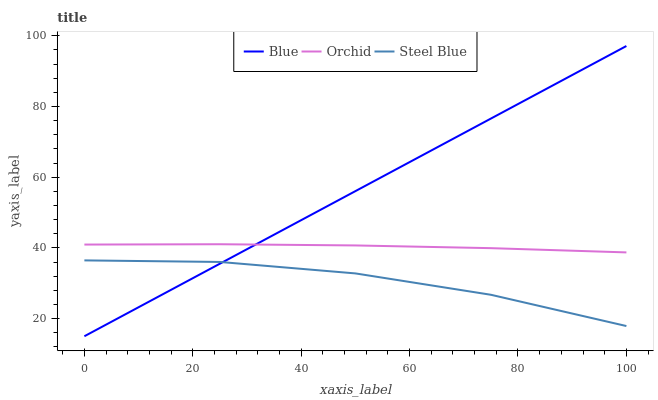Does Steel Blue have the minimum area under the curve?
Answer yes or no. Yes. Does Blue have the maximum area under the curve?
Answer yes or no. Yes. Does Orchid have the minimum area under the curve?
Answer yes or no. No. Does Orchid have the maximum area under the curve?
Answer yes or no. No. Is Blue the smoothest?
Answer yes or no. Yes. Is Steel Blue the roughest?
Answer yes or no. Yes. Is Orchid the smoothest?
Answer yes or no. No. Is Orchid the roughest?
Answer yes or no. No. Does Blue have the lowest value?
Answer yes or no. Yes. Does Steel Blue have the lowest value?
Answer yes or no. No. Does Blue have the highest value?
Answer yes or no. Yes. Does Orchid have the highest value?
Answer yes or no. No. Is Steel Blue less than Orchid?
Answer yes or no. Yes. Is Orchid greater than Steel Blue?
Answer yes or no. Yes. Does Blue intersect Orchid?
Answer yes or no. Yes. Is Blue less than Orchid?
Answer yes or no. No. Is Blue greater than Orchid?
Answer yes or no. No. Does Steel Blue intersect Orchid?
Answer yes or no. No. 